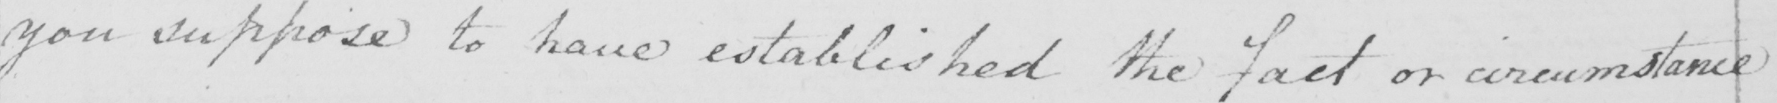Please provide the text content of this handwritten line. you suppose to have established the fact or circumstance 